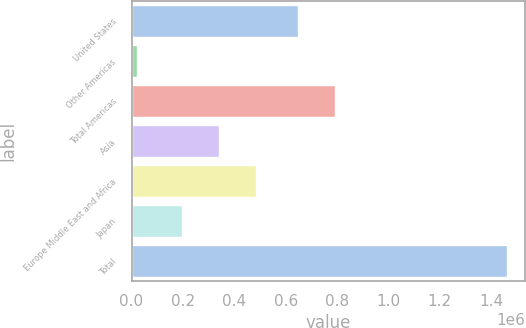<chart> <loc_0><loc_0><loc_500><loc_500><bar_chart><fcel>United States<fcel>Other Americas<fcel>Total Americas<fcel>Asia<fcel>Europe Middle East and Africa<fcel>Japan<fcel>Total<nl><fcel>648714<fcel>22940<fcel>792432<fcel>339522<fcel>483239<fcel>195804<fcel>1.46012e+06<nl></chart> 